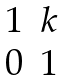Convert formula to latex. <formula><loc_0><loc_0><loc_500><loc_500>\begin{matrix} 1 & k \\ 0 & 1 \end{matrix}</formula> 